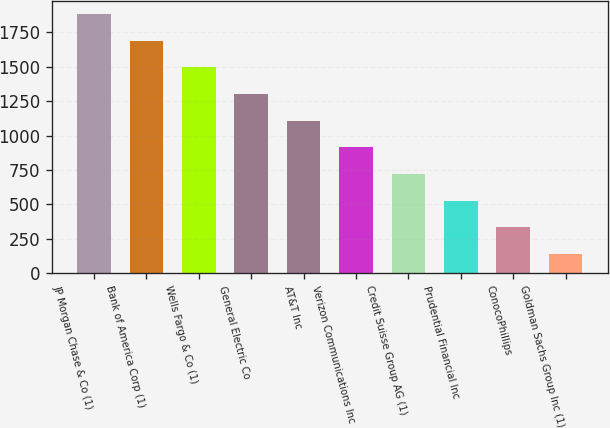Convert chart. <chart><loc_0><loc_0><loc_500><loc_500><bar_chart><fcel>JP Morgan Chase & Co (1)<fcel>Bank of America Corp (1)<fcel>Wells Fargo & Co (1)<fcel>General Electric Co<fcel>AT&T Inc<fcel>Verizon Communications Inc<fcel>Credit Suisse Group AG (1)<fcel>Prudential Financial Inc<fcel>ConocoPhillips<fcel>Goldman Sachs Group Inc (1)<nl><fcel>1880.84<fcel>1687.38<fcel>1493.92<fcel>1300.46<fcel>1107<fcel>913.54<fcel>720.08<fcel>526.62<fcel>333.16<fcel>139.7<nl></chart> 